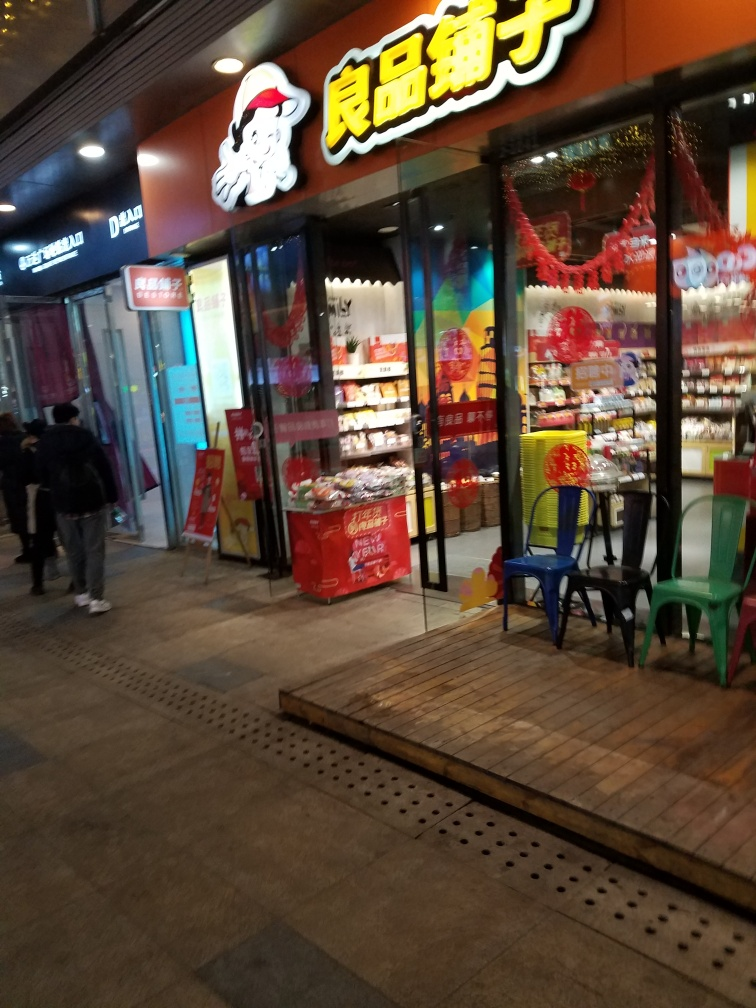The decorations seem festive; is there a holiday or celebration that this might be related to? The red decorations hanging in the store's window and doorway are reminiscent of traditional festive ornaments that could be associated with Chinese New Year or other significant cultural celebrations. These decorations often symbolize good fortune and happiness and are used to mark important occasions, as they seem to be doing here, adding an air of festivity to the storefront. 